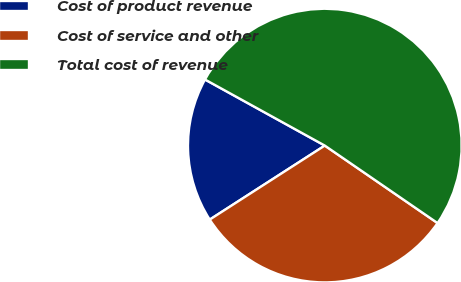Convert chart to OTSL. <chart><loc_0><loc_0><loc_500><loc_500><pie_chart><fcel>Cost of product revenue<fcel>Cost of service and other<fcel>Total cost of revenue<nl><fcel>17.12%<fcel>31.32%<fcel>51.56%<nl></chart> 